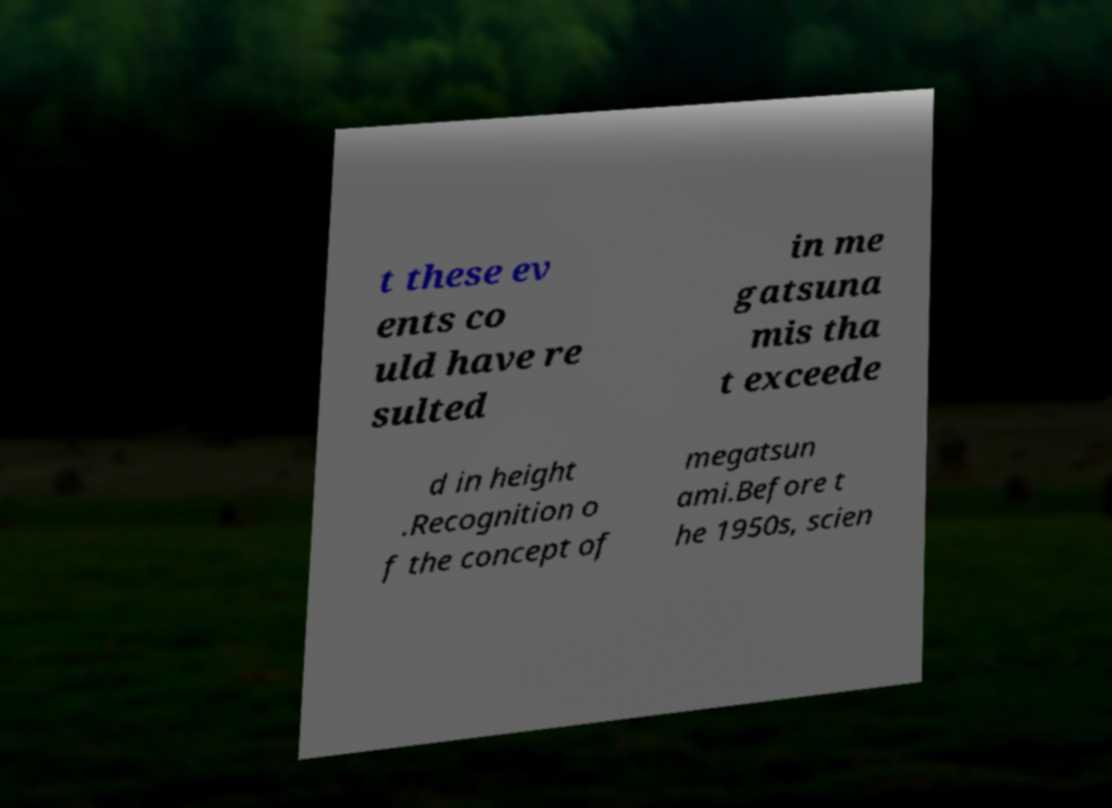Could you assist in decoding the text presented in this image and type it out clearly? t these ev ents co uld have re sulted in me gatsuna mis tha t exceede d in height .Recognition o f the concept of megatsun ami.Before t he 1950s, scien 